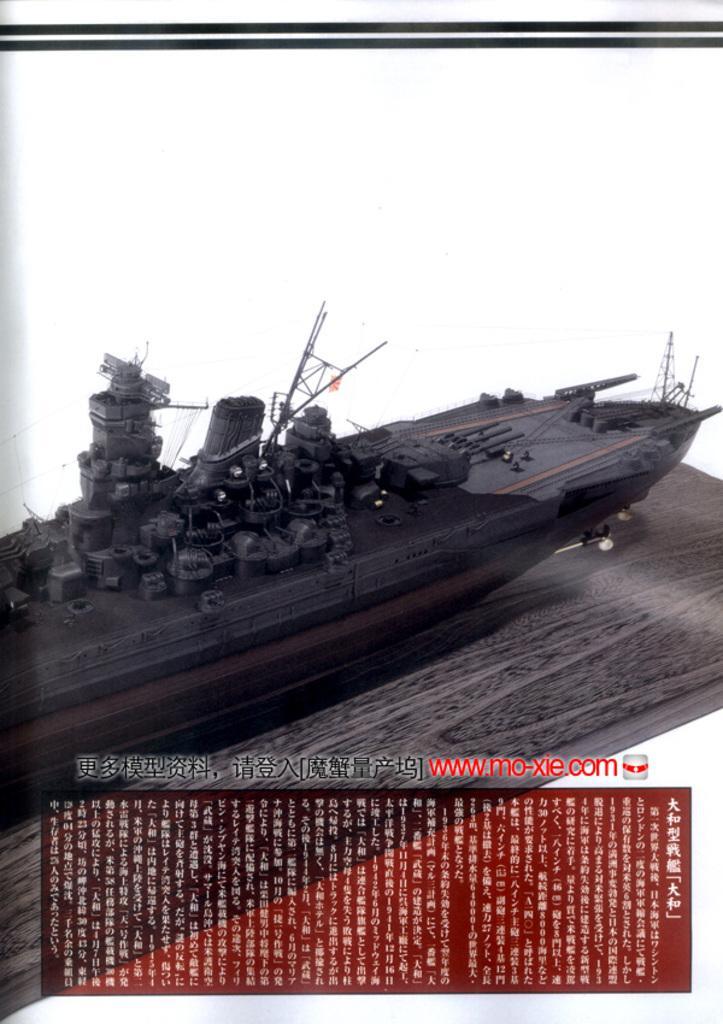How would you summarize this image in a sentence or two? In this picture I can see picture of a warship and text at the bottom of the picture. 